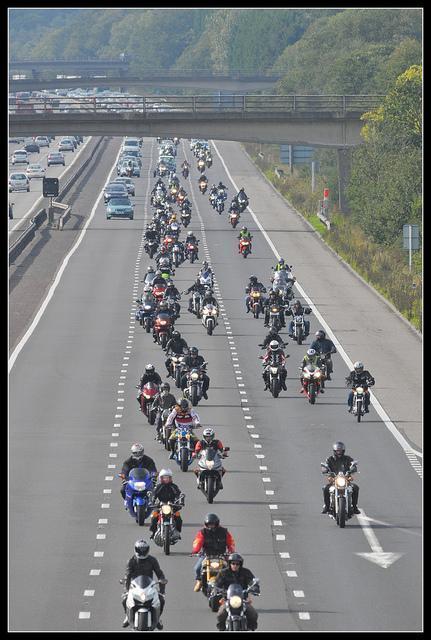How many motorcycles are there?
Give a very brief answer. 2. 